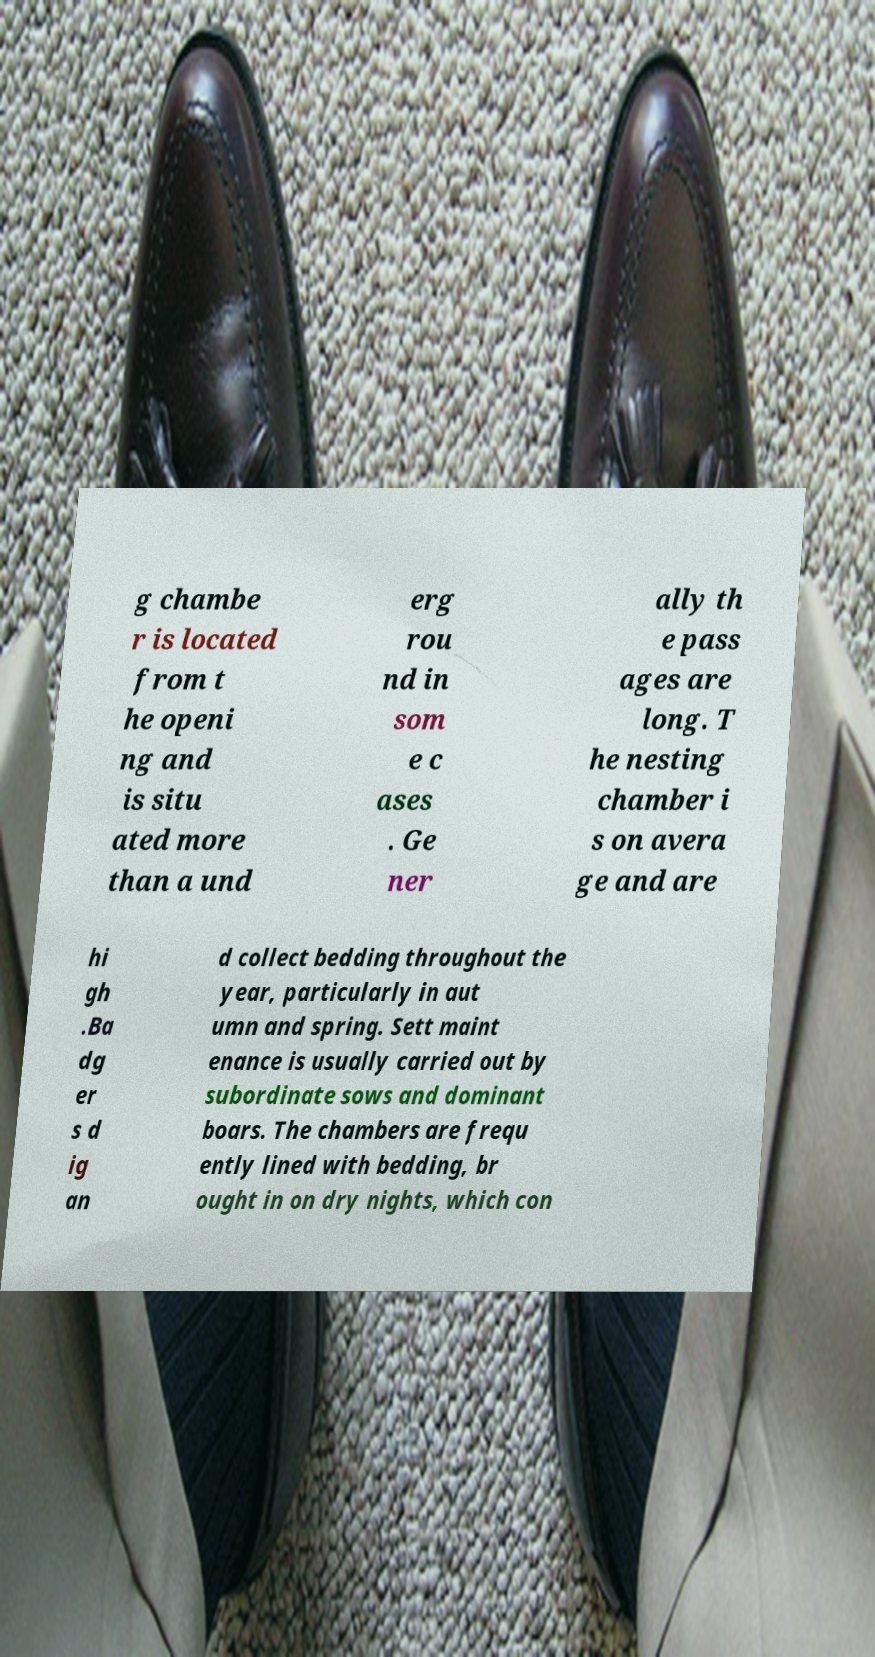For documentation purposes, I need the text within this image transcribed. Could you provide that? g chambe r is located from t he openi ng and is situ ated more than a und erg rou nd in som e c ases . Ge ner ally th e pass ages are long. T he nesting chamber i s on avera ge and are hi gh .Ba dg er s d ig an d collect bedding throughout the year, particularly in aut umn and spring. Sett maint enance is usually carried out by subordinate sows and dominant boars. The chambers are frequ ently lined with bedding, br ought in on dry nights, which con 